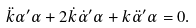Convert formula to latex. <formula><loc_0><loc_0><loc_500><loc_500>\ddot { k } \alpha ^ { \prime } \alpha + 2 \dot { k } \dot { \alpha } ^ { \prime } \alpha + k \ddot { \alpha } ^ { \prime } \alpha = 0 .</formula> 